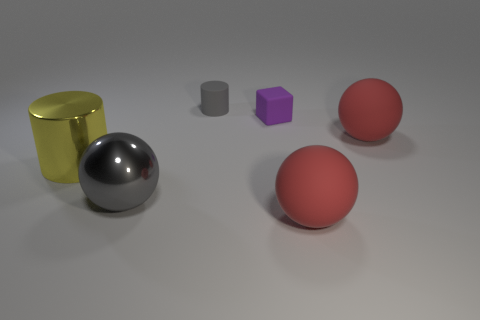Is the material of the large red object in front of the large shiny cylinder the same as the tiny object in front of the gray cylinder?
Your answer should be very brief. Yes. There is a matte thing behind the purple rubber cube; is it the same size as the large yellow thing?
Give a very brief answer. No. There is a metal cylinder; is its color the same as the large rubber sphere that is in front of the big gray metal sphere?
Your answer should be compact. No. There is a small rubber thing that is the same color as the large metallic sphere; what shape is it?
Ensure brevity in your answer.  Cylinder. What is the shape of the small gray thing?
Your answer should be very brief. Cylinder. Is the small matte cube the same color as the tiny rubber cylinder?
Your answer should be very brief. No. How many objects are either things that are behind the matte cube or gray shiny cubes?
Give a very brief answer. 1. The gray sphere that is the same material as the yellow cylinder is what size?
Offer a terse response. Large. Are there more cylinders right of the tiny purple matte block than tiny things?
Offer a terse response. No. Do the tiny gray object and the gray thing that is on the left side of the tiny cylinder have the same shape?
Ensure brevity in your answer.  No. 